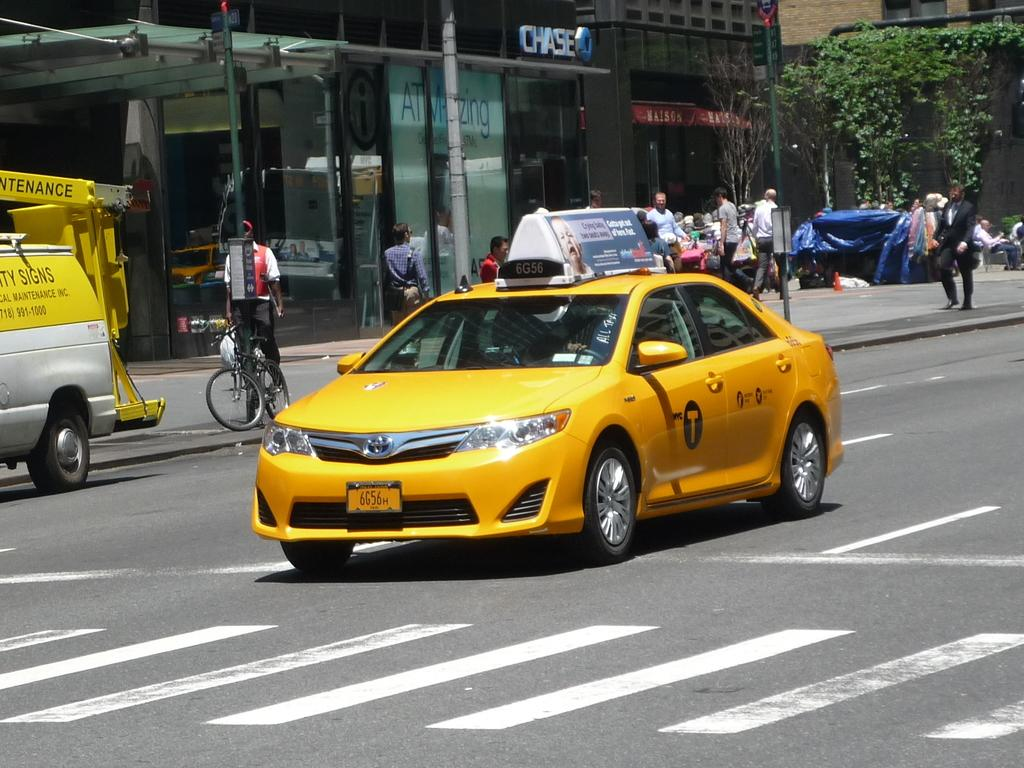<image>
Share a concise interpretation of the image provided. A yellow taxi cab is driving down a street while a logo for chase bank is visible in the back. 